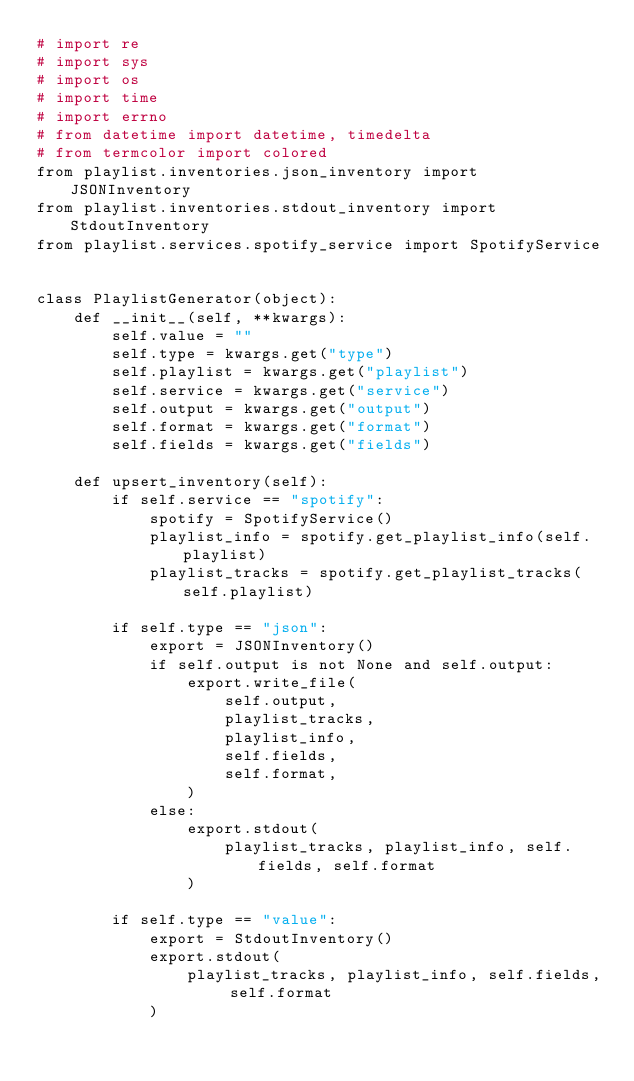Convert code to text. <code><loc_0><loc_0><loc_500><loc_500><_Python_># import re
# import sys
# import os
# import time
# import errno
# from datetime import datetime, timedelta
# from termcolor import colored
from playlist.inventories.json_inventory import JSONInventory
from playlist.inventories.stdout_inventory import StdoutInventory
from playlist.services.spotify_service import SpotifyService


class PlaylistGenerator(object):
    def __init__(self, **kwargs):
        self.value = ""
        self.type = kwargs.get("type")
        self.playlist = kwargs.get("playlist")
        self.service = kwargs.get("service")
        self.output = kwargs.get("output")
        self.format = kwargs.get("format")
        self.fields = kwargs.get("fields")

    def upsert_inventory(self):
        if self.service == "spotify":
            spotify = SpotifyService()
            playlist_info = spotify.get_playlist_info(self.playlist)
            playlist_tracks = spotify.get_playlist_tracks(self.playlist)

        if self.type == "json":
            export = JSONInventory()
            if self.output is not None and self.output:
                export.write_file(
                    self.output,
                    playlist_tracks,
                    playlist_info,
                    self.fields,
                    self.format,
                )
            else:
                export.stdout(
                    playlist_tracks, playlist_info, self.fields, self.format
                )

        if self.type == "value":
            export = StdoutInventory()
            export.stdout(
                playlist_tracks, playlist_info, self.fields, self.format
            )
</code> 